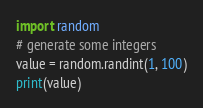<code> <loc_0><loc_0><loc_500><loc_500><_Python_>import random
# generate some integers
value = random.randint(1, 100)
print(value)</code> 